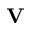<formula> <loc_0><loc_0><loc_500><loc_500>V</formula> 